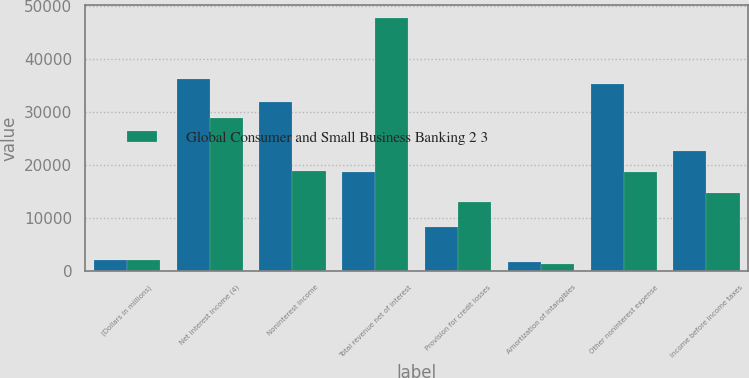<chart> <loc_0><loc_0><loc_500><loc_500><stacked_bar_chart><ecel><fcel>(Dollars in millions)<fcel>Net interest income (4)<fcel>Noninterest income<fcel>Total revenue net of interest<fcel>Provision for credit losses<fcel>Amortization of intangibles<fcel>Other noninterest expense<fcel>Income before income taxes<nl><fcel>nan<fcel>2007<fcel>36182<fcel>31886<fcel>18724<fcel>8385<fcel>1676<fcel>35334<fcel>22673<nl><fcel>Global Consumer and Small Business Banking 2 3<fcel>2007<fcel>28809<fcel>18873<fcel>47682<fcel>12929<fcel>1336<fcel>18724<fcel>14693<nl></chart> 